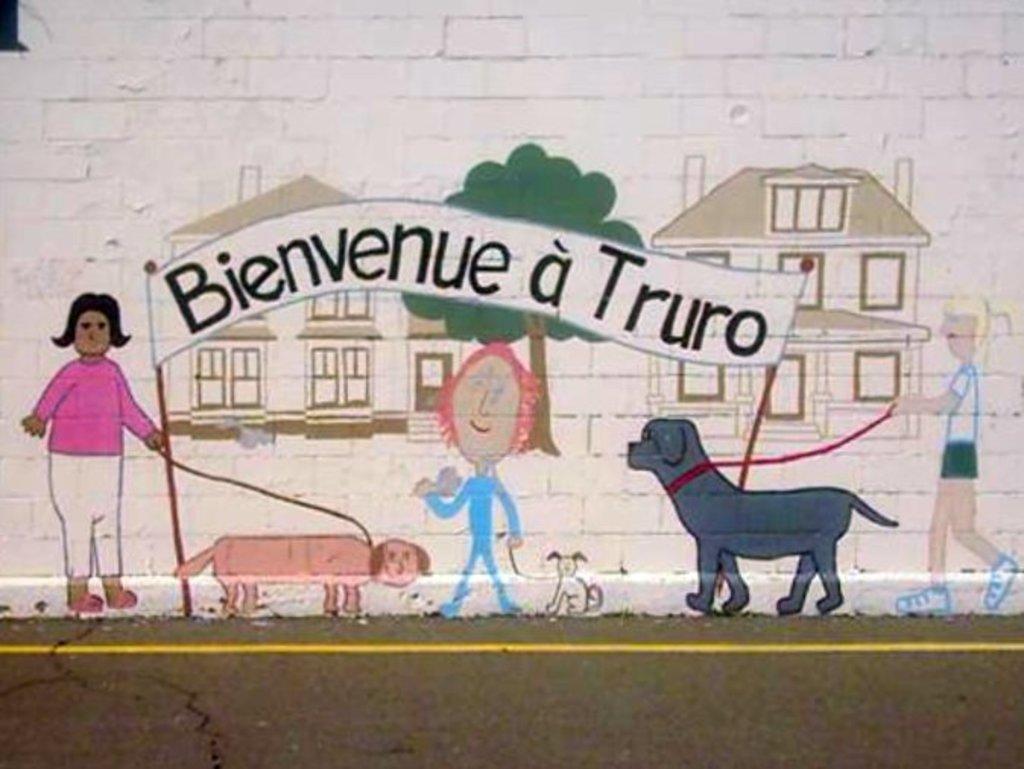Please provide a concise description of this image. This picture is a painting on the wall. In this image, on the right side, we can see a painting of a dog in which its collar rope is held by a girl. On the left side, we can also see another girl holding the collar rope of the dog. In the middle of the image, we can see a person holding collar rope of a dog, hoardings. In the background of the paintings, we can see trees and buildings. At the bottom, we can see a road. 